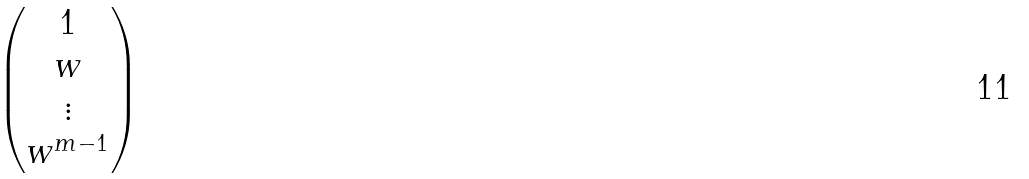Convert formula to latex. <formula><loc_0><loc_0><loc_500><loc_500>\begin{pmatrix} 1 \\ w \\ \vdots \\ w ^ { m - 1 } \end{pmatrix}</formula> 